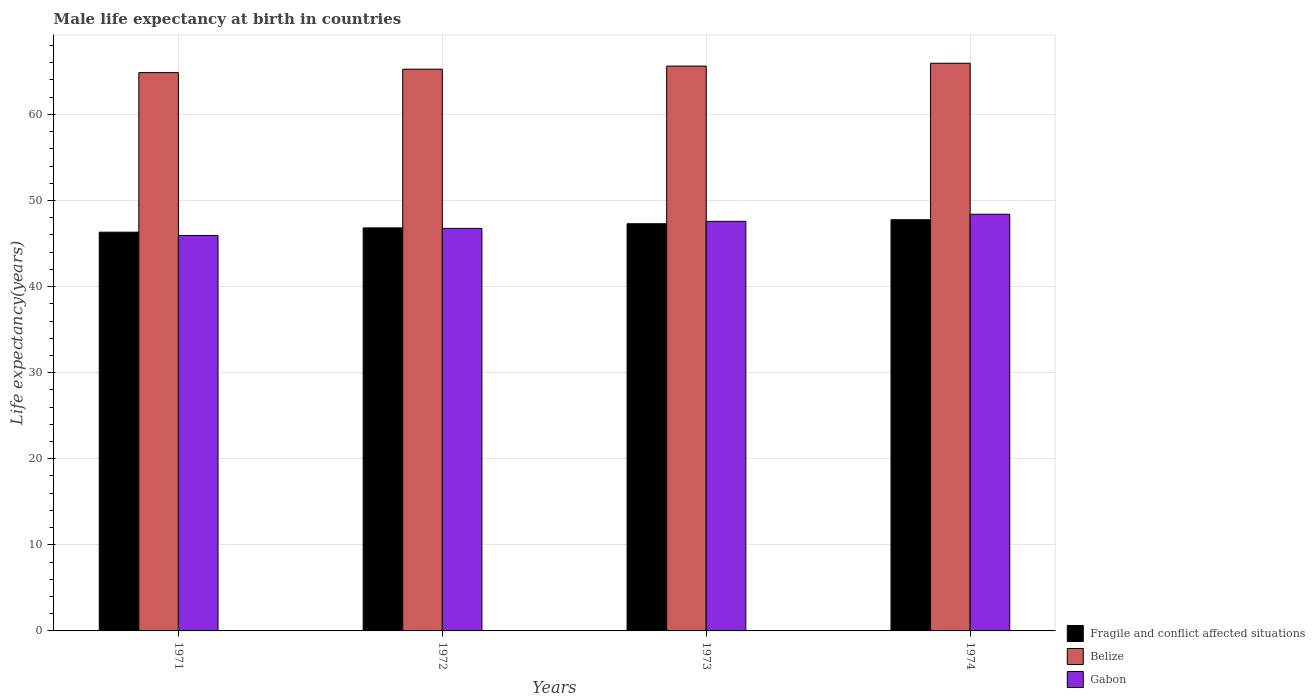Are the number of bars per tick equal to the number of legend labels?
Your answer should be compact. Yes. How many bars are there on the 2nd tick from the left?
Your answer should be very brief. 3. How many bars are there on the 4th tick from the right?
Offer a very short reply. 3. What is the male life expectancy at birth in Gabon in 1972?
Your answer should be very brief. 46.76. Across all years, what is the maximum male life expectancy at birth in Fragile and conflict affected situations?
Ensure brevity in your answer.  47.77. Across all years, what is the minimum male life expectancy at birth in Fragile and conflict affected situations?
Provide a succinct answer. 46.32. In which year was the male life expectancy at birth in Belize maximum?
Offer a very short reply. 1974. What is the total male life expectancy at birth in Belize in the graph?
Ensure brevity in your answer.  261.68. What is the difference between the male life expectancy at birth in Belize in 1971 and that in 1974?
Ensure brevity in your answer.  -1.09. What is the difference between the male life expectancy at birth in Fragile and conflict affected situations in 1973 and the male life expectancy at birth in Gabon in 1972?
Keep it short and to the point. 0.54. What is the average male life expectancy at birth in Gabon per year?
Provide a succinct answer. 47.17. In the year 1974, what is the difference between the male life expectancy at birth in Gabon and male life expectancy at birth in Belize?
Ensure brevity in your answer.  -17.54. What is the ratio of the male life expectancy at birth in Belize in 1973 to that in 1974?
Your answer should be very brief. 1. Is the male life expectancy at birth in Gabon in 1971 less than that in 1973?
Keep it short and to the point. Yes. Is the difference between the male life expectancy at birth in Gabon in 1971 and 1973 greater than the difference between the male life expectancy at birth in Belize in 1971 and 1973?
Give a very brief answer. No. What is the difference between the highest and the second highest male life expectancy at birth in Gabon?
Make the answer very short. 0.82. What is the difference between the highest and the lowest male life expectancy at birth in Fragile and conflict affected situations?
Offer a terse response. 1.45. In how many years, is the male life expectancy at birth in Belize greater than the average male life expectancy at birth in Belize taken over all years?
Your answer should be compact. 2. What does the 1st bar from the left in 1972 represents?
Offer a very short reply. Fragile and conflict affected situations. What does the 1st bar from the right in 1973 represents?
Offer a very short reply. Gabon. How many bars are there?
Your response must be concise. 12. Are all the bars in the graph horizontal?
Your answer should be compact. No. How many years are there in the graph?
Make the answer very short. 4. Does the graph contain any zero values?
Ensure brevity in your answer.  No. What is the title of the graph?
Make the answer very short. Male life expectancy at birth in countries. Does "Zambia" appear as one of the legend labels in the graph?
Offer a very short reply. No. What is the label or title of the Y-axis?
Give a very brief answer. Life expectancy(years). What is the Life expectancy(years) of Fragile and conflict affected situations in 1971?
Give a very brief answer. 46.32. What is the Life expectancy(years) in Belize in 1971?
Keep it short and to the point. 64.86. What is the Life expectancy(years) of Gabon in 1971?
Ensure brevity in your answer.  45.94. What is the Life expectancy(years) of Fragile and conflict affected situations in 1972?
Provide a short and direct response. 46.82. What is the Life expectancy(years) of Belize in 1972?
Your response must be concise. 65.26. What is the Life expectancy(years) of Gabon in 1972?
Provide a succinct answer. 46.76. What is the Life expectancy(years) in Fragile and conflict affected situations in 1973?
Your answer should be very brief. 47.3. What is the Life expectancy(years) of Belize in 1973?
Provide a short and direct response. 65.62. What is the Life expectancy(years) of Gabon in 1973?
Give a very brief answer. 47.58. What is the Life expectancy(years) in Fragile and conflict affected situations in 1974?
Give a very brief answer. 47.77. What is the Life expectancy(years) of Belize in 1974?
Keep it short and to the point. 65.94. What is the Life expectancy(years) in Gabon in 1974?
Make the answer very short. 48.41. Across all years, what is the maximum Life expectancy(years) in Fragile and conflict affected situations?
Your answer should be very brief. 47.77. Across all years, what is the maximum Life expectancy(years) in Belize?
Offer a terse response. 65.94. Across all years, what is the maximum Life expectancy(years) of Gabon?
Your answer should be very brief. 48.41. Across all years, what is the minimum Life expectancy(years) in Fragile and conflict affected situations?
Provide a short and direct response. 46.32. Across all years, what is the minimum Life expectancy(years) in Belize?
Provide a succinct answer. 64.86. Across all years, what is the minimum Life expectancy(years) of Gabon?
Your answer should be compact. 45.94. What is the total Life expectancy(years) in Fragile and conflict affected situations in the graph?
Keep it short and to the point. 188.21. What is the total Life expectancy(years) in Belize in the graph?
Give a very brief answer. 261.68. What is the total Life expectancy(years) in Gabon in the graph?
Offer a very short reply. 188.69. What is the difference between the Life expectancy(years) of Fragile and conflict affected situations in 1971 and that in 1972?
Offer a very short reply. -0.5. What is the difference between the Life expectancy(years) in Belize in 1971 and that in 1972?
Your response must be concise. -0.4. What is the difference between the Life expectancy(years) of Gabon in 1971 and that in 1972?
Offer a terse response. -0.82. What is the difference between the Life expectancy(years) of Fragile and conflict affected situations in 1971 and that in 1973?
Your answer should be compact. -0.98. What is the difference between the Life expectancy(years) in Belize in 1971 and that in 1973?
Your answer should be very brief. -0.76. What is the difference between the Life expectancy(years) in Gabon in 1971 and that in 1973?
Provide a succinct answer. -1.65. What is the difference between the Life expectancy(years) in Fragile and conflict affected situations in 1971 and that in 1974?
Your answer should be very brief. -1.45. What is the difference between the Life expectancy(years) in Belize in 1971 and that in 1974?
Make the answer very short. -1.08. What is the difference between the Life expectancy(years) in Gabon in 1971 and that in 1974?
Ensure brevity in your answer.  -2.47. What is the difference between the Life expectancy(years) in Fragile and conflict affected situations in 1972 and that in 1973?
Make the answer very short. -0.48. What is the difference between the Life expectancy(years) of Belize in 1972 and that in 1973?
Ensure brevity in your answer.  -0.36. What is the difference between the Life expectancy(years) of Gabon in 1972 and that in 1973?
Offer a very short reply. -0.82. What is the difference between the Life expectancy(years) of Fragile and conflict affected situations in 1972 and that in 1974?
Ensure brevity in your answer.  -0.95. What is the difference between the Life expectancy(years) in Belize in 1972 and that in 1974?
Provide a short and direct response. -0.69. What is the difference between the Life expectancy(years) of Gabon in 1972 and that in 1974?
Provide a short and direct response. -1.65. What is the difference between the Life expectancy(years) in Fragile and conflict affected situations in 1973 and that in 1974?
Offer a very short reply. -0.46. What is the difference between the Life expectancy(years) of Belize in 1973 and that in 1974?
Offer a terse response. -0.33. What is the difference between the Life expectancy(years) of Gabon in 1973 and that in 1974?
Ensure brevity in your answer.  -0.82. What is the difference between the Life expectancy(years) in Fragile and conflict affected situations in 1971 and the Life expectancy(years) in Belize in 1972?
Offer a terse response. -18.94. What is the difference between the Life expectancy(years) in Fragile and conflict affected situations in 1971 and the Life expectancy(years) in Gabon in 1972?
Your response must be concise. -0.44. What is the difference between the Life expectancy(years) in Belize in 1971 and the Life expectancy(years) in Gabon in 1972?
Offer a terse response. 18.1. What is the difference between the Life expectancy(years) in Fragile and conflict affected situations in 1971 and the Life expectancy(years) in Belize in 1973?
Offer a terse response. -19.3. What is the difference between the Life expectancy(years) in Fragile and conflict affected situations in 1971 and the Life expectancy(years) in Gabon in 1973?
Your answer should be very brief. -1.26. What is the difference between the Life expectancy(years) in Belize in 1971 and the Life expectancy(years) in Gabon in 1973?
Provide a succinct answer. 17.28. What is the difference between the Life expectancy(years) of Fragile and conflict affected situations in 1971 and the Life expectancy(years) of Belize in 1974?
Keep it short and to the point. -19.62. What is the difference between the Life expectancy(years) of Fragile and conflict affected situations in 1971 and the Life expectancy(years) of Gabon in 1974?
Your answer should be very brief. -2.09. What is the difference between the Life expectancy(years) of Belize in 1971 and the Life expectancy(years) of Gabon in 1974?
Make the answer very short. 16.45. What is the difference between the Life expectancy(years) of Fragile and conflict affected situations in 1972 and the Life expectancy(years) of Belize in 1973?
Your answer should be compact. -18.8. What is the difference between the Life expectancy(years) of Fragile and conflict affected situations in 1972 and the Life expectancy(years) of Gabon in 1973?
Ensure brevity in your answer.  -0.76. What is the difference between the Life expectancy(years) in Belize in 1972 and the Life expectancy(years) in Gabon in 1973?
Offer a terse response. 17.67. What is the difference between the Life expectancy(years) in Fragile and conflict affected situations in 1972 and the Life expectancy(years) in Belize in 1974?
Provide a short and direct response. -19.13. What is the difference between the Life expectancy(years) in Fragile and conflict affected situations in 1972 and the Life expectancy(years) in Gabon in 1974?
Ensure brevity in your answer.  -1.59. What is the difference between the Life expectancy(years) of Belize in 1972 and the Life expectancy(years) of Gabon in 1974?
Your answer should be very brief. 16.85. What is the difference between the Life expectancy(years) in Fragile and conflict affected situations in 1973 and the Life expectancy(years) in Belize in 1974?
Offer a terse response. -18.64. What is the difference between the Life expectancy(years) of Fragile and conflict affected situations in 1973 and the Life expectancy(years) of Gabon in 1974?
Give a very brief answer. -1.1. What is the difference between the Life expectancy(years) in Belize in 1973 and the Life expectancy(years) in Gabon in 1974?
Give a very brief answer. 17.21. What is the average Life expectancy(years) in Fragile and conflict affected situations per year?
Your answer should be compact. 47.05. What is the average Life expectancy(years) in Belize per year?
Provide a succinct answer. 65.42. What is the average Life expectancy(years) in Gabon per year?
Give a very brief answer. 47.17. In the year 1971, what is the difference between the Life expectancy(years) in Fragile and conflict affected situations and Life expectancy(years) in Belize?
Your answer should be compact. -18.54. In the year 1971, what is the difference between the Life expectancy(years) in Fragile and conflict affected situations and Life expectancy(years) in Gabon?
Your answer should be very brief. 0.38. In the year 1971, what is the difference between the Life expectancy(years) of Belize and Life expectancy(years) of Gabon?
Give a very brief answer. 18.92. In the year 1972, what is the difference between the Life expectancy(years) in Fragile and conflict affected situations and Life expectancy(years) in Belize?
Provide a succinct answer. -18.44. In the year 1972, what is the difference between the Life expectancy(years) in Fragile and conflict affected situations and Life expectancy(years) in Gabon?
Make the answer very short. 0.06. In the year 1972, what is the difference between the Life expectancy(years) of Belize and Life expectancy(years) of Gabon?
Your response must be concise. 18.5. In the year 1973, what is the difference between the Life expectancy(years) of Fragile and conflict affected situations and Life expectancy(years) of Belize?
Ensure brevity in your answer.  -18.31. In the year 1973, what is the difference between the Life expectancy(years) of Fragile and conflict affected situations and Life expectancy(years) of Gabon?
Provide a succinct answer. -0.28. In the year 1973, what is the difference between the Life expectancy(years) of Belize and Life expectancy(years) of Gabon?
Offer a very short reply. 18.03. In the year 1974, what is the difference between the Life expectancy(years) of Fragile and conflict affected situations and Life expectancy(years) of Belize?
Your answer should be compact. -18.18. In the year 1974, what is the difference between the Life expectancy(years) in Fragile and conflict affected situations and Life expectancy(years) in Gabon?
Make the answer very short. -0.64. In the year 1974, what is the difference between the Life expectancy(years) of Belize and Life expectancy(years) of Gabon?
Ensure brevity in your answer.  17.54. What is the ratio of the Life expectancy(years) of Fragile and conflict affected situations in 1971 to that in 1972?
Give a very brief answer. 0.99. What is the ratio of the Life expectancy(years) of Gabon in 1971 to that in 1972?
Offer a very short reply. 0.98. What is the ratio of the Life expectancy(years) in Fragile and conflict affected situations in 1971 to that in 1973?
Offer a very short reply. 0.98. What is the ratio of the Life expectancy(years) in Gabon in 1971 to that in 1973?
Your answer should be very brief. 0.97. What is the ratio of the Life expectancy(years) of Fragile and conflict affected situations in 1971 to that in 1974?
Make the answer very short. 0.97. What is the ratio of the Life expectancy(years) in Belize in 1971 to that in 1974?
Ensure brevity in your answer.  0.98. What is the ratio of the Life expectancy(years) in Gabon in 1971 to that in 1974?
Provide a short and direct response. 0.95. What is the ratio of the Life expectancy(years) in Fragile and conflict affected situations in 1972 to that in 1973?
Give a very brief answer. 0.99. What is the ratio of the Life expectancy(years) of Gabon in 1972 to that in 1973?
Provide a succinct answer. 0.98. What is the ratio of the Life expectancy(years) of Fragile and conflict affected situations in 1972 to that in 1974?
Offer a terse response. 0.98. What is the ratio of the Life expectancy(years) of Belize in 1972 to that in 1974?
Make the answer very short. 0.99. What is the ratio of the Life expectancy(years) of Fragile and conflict affected situations in 1973 to that in 1974?
Ensure brevity in your answer.  0.99. What is the ratio of the Life expectancy(years) of Gabon in 1973 to that in 1974?
Keep it short and to the point. 0.98. What is the difference between the highest and the second highest Life expectancy(years) of Fragile and conflict affected situations?
Provide a short and direct response. 0.46. What is the difference between the highest and the second highest Life expectancy(years) of Belize?
Ensure brevity in your answer.  0.33. What is the difference between the highest and the second highest Life expectancy(years) of Gabon?
Your response must be concise. 0.82. What is the difference between the highest and the lowest Life expectancy(years) of Fragile and conflict affected situations?
Offer a very short reply. 1.45. What is the difference between the highest and the lowest Life expectancy(years) in Belize?
Keep it short and to the point. 1.08. What is the difference between the highest and the lowest Life expectancy(years) in Gabon?
Keep it short and to the point. 2.47. 